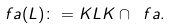Convert formula to latex. <formula><loc_0><loc_0><loc_500><loc_500>\ f a ( L ) \colon = K L K \cap \ f a .</formula> 